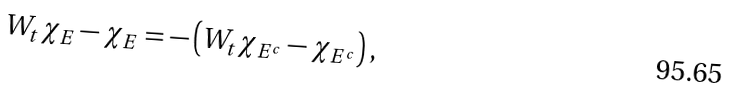<formula> <loc_0><loc_0><loc_500><loc_500>W _ { t } \chi _ { E } - \chi _ { E } = - \left ( W _ { t } \chi _ { E ^ { c } } - \chi _ { E ^ { c } } \right ) ,</formula> 